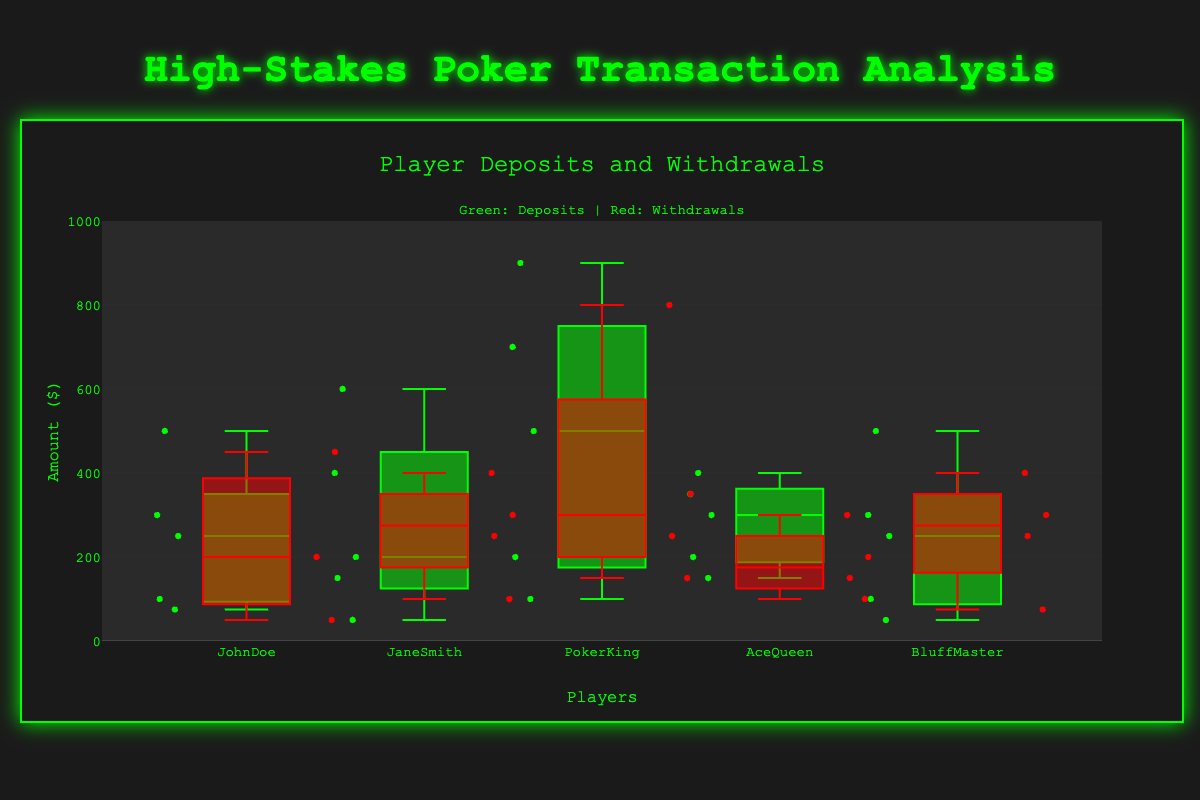How many players' transactions are shown in the chart? The chart shows transactions for "JohnDoe," "JaneSmith," "PokerKing," "AceQueen," and "BluffMaster." This information can be derived from the x-axis labels showing player names.
Answer: 5 What's the color used for representing deposits and withdrawals? Deposits are shown in green, and withdrawals are shown in red, as indicated by the text annotation on the chart.
Answer: Green: Deposits, Red: Withdrawals Which player has the highest median deposit amount? By observing the middle line inside each green box representing deposits, we can identify that "PokerKing" has the highest median deposit amount.
Answer: PokerKing What is the lowest withdrawal amount made by "BluffMaster"? The lowest point within the red box plot for "BluffMaster" indicates the minimum value of his withdrawals.
Answer: 75 Which player made the highest single withdrawal? The highest point across all red box plots represents the maximum single withdrawal, which is by "PokerKing."
Answer: PokerKing Which player has the most variable deposits? The variability in deposits can be inferred from the range covered by the box plot (length of the boxes and whiskers). "PokerKing" shows the greatest spread for deposits.
Answer: PokerKing Compare the median withdrawals of "JaneSmith" and "AceQueen." Who has the higher median? The middle line inside the red boxes for "JaneSmith" and "AceQueen" indicate their medians. "JaneSmith" has a higher median withdrawal amount.
Answer: JaneSmith Which player has the smallest interquartile range (IQR) for deposits? The IQR can be determined by the height of the green boxes. "BluffMaster" has the smallest IQR for deposits as his box is the shortest.
Answer: BluffMaster What is the range of deposit amounts for "JohnDoe"? The range is identified by the minimum and maximum values in the green box plot. For "JohnDoe," it ranges from 75 to 500.
Answer: 75 to 500 